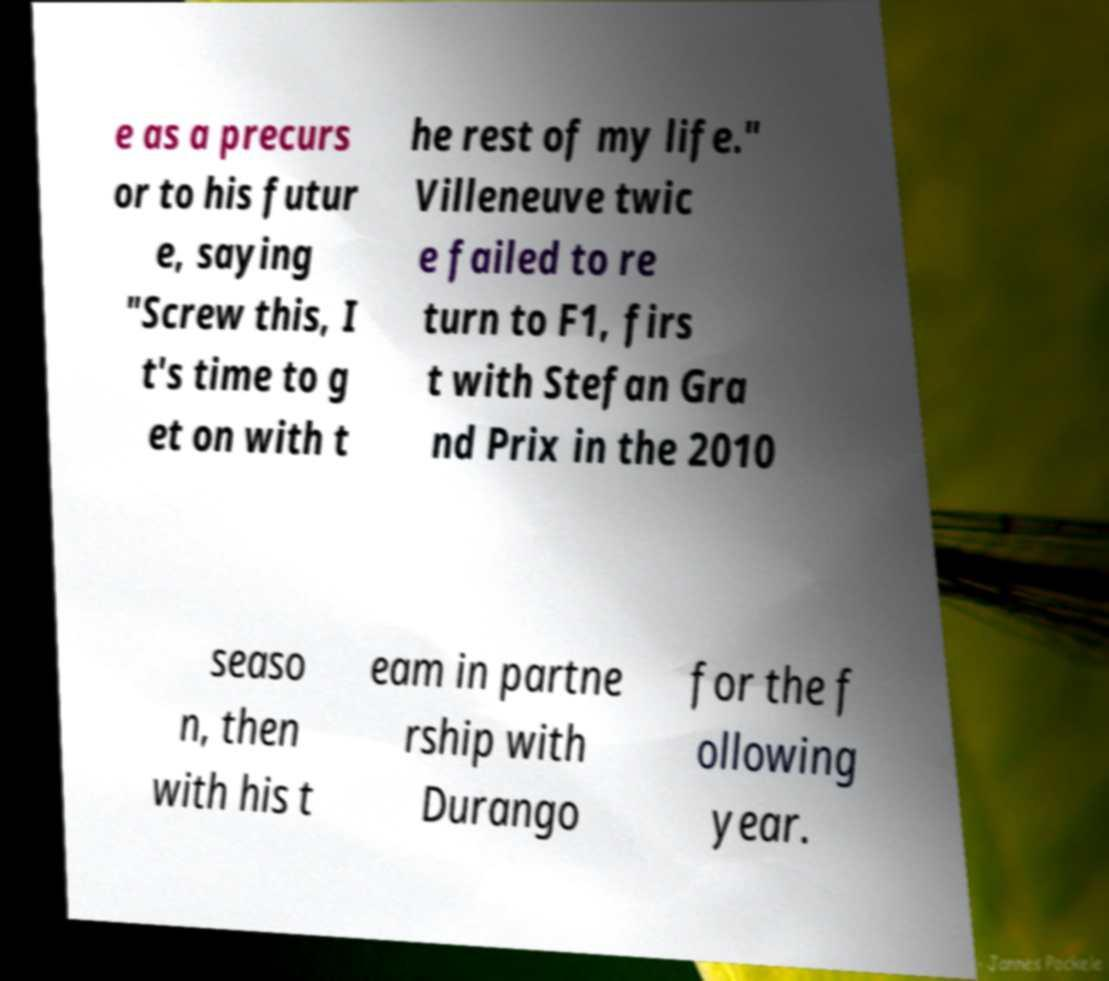What messages or text are displayed in this image? I need them in a readable, typed format. e as a precurs or to his futur e, saying "Screw this, I t's time to g et on with t he rest of my life." Villeneuve twic e failed to re turn to F1, firs t with Stefan Gra nd Prix in the 2010 seaso n, then with his t eam in partne rship with Durango for the f ollowing year. 